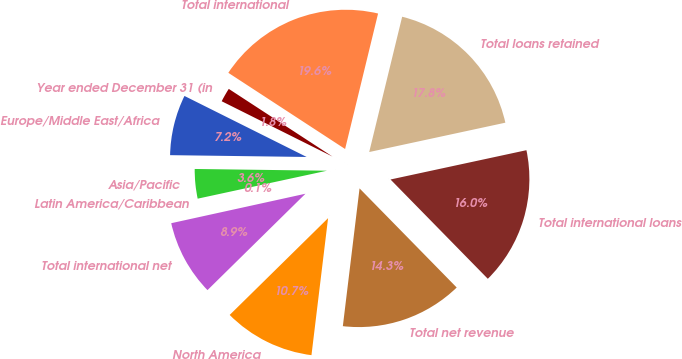Convert chart to OTSL. <chart><loc_0><loc_0><loc_500><loc_500><pie_chart><fcel>Year ended December 31 (in<fcel>Europe/Middle East/Africa<fcel>Asia/Pacific<fcel>Latin America/Caribbean<fcel>Total international net<fcel>North America<fcel>Total net revenue<fcel>Total international loans<fcel>Total loans retained<fcel>Total international<nl><fcel>1.83%<fcel>7.16%<fcel>3.6%<fcel>0.05%<fcel>8.93%<fcel>10.71%<fcel>14.26%<fcel>16.04%<fcel>17.82%<fcel>19.6%<nl></chart> 